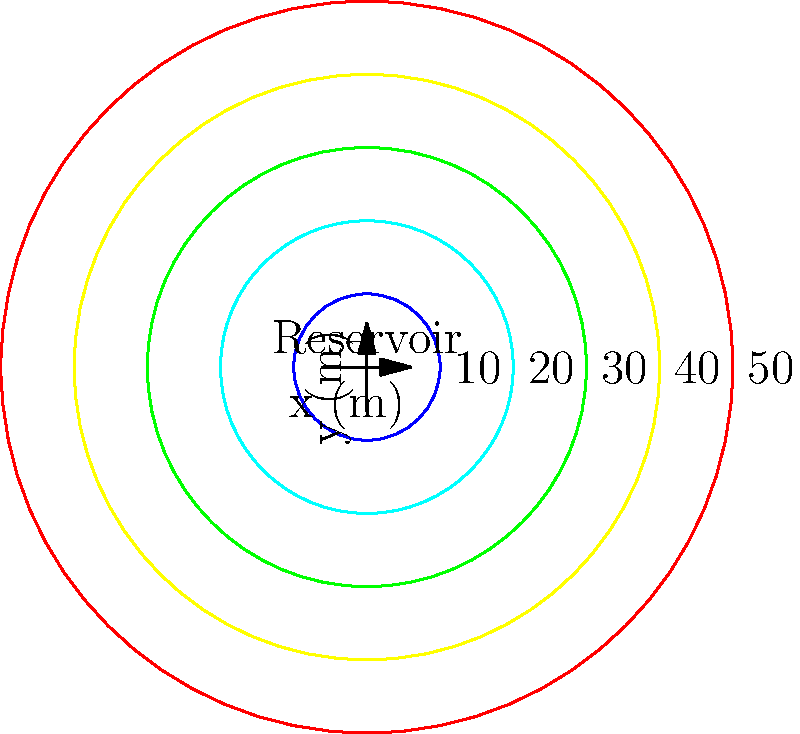A circular reservoir affected by mining runoff is represented by the contour map above, where each contour line indicates a depth in meters. If the reservoir has a maximum depth of 50 meters at its center and a radius of 50 meters, calculate its total volume in cubic meters. Assume the reservoir has a conical shape. To calculate the volume of the conical reservoir, we'll follow these steps:

1) The formula for the volume of a cone is:
   $$V = \frac{1}{3}\pi r^2 h$$
   where $r$ is the radius of the base and $h$ is the height.

2) From the given information:
   Radius ($r$) = 50 meters
   Height ($h$) = 50 meters

3) Substituting these values into the formula:
   $$V = \frac{1}{3}\pi (50\text{ m})^2 (50\text{ m})$$

4) Simplify:
   $$V = \frac{1}{3}\pi (2500\text{ m}^2) (50\text{ m})$$
   $$V = \frac{1}{3}\pi (125000\text{ m}^3)$$

5) Calculate:
   $$V \approx 130899.7\text{ m}^3$$

6) Rounding to the nearest whole number:
   $$V \approx 130900\text{ m}^3$$

Therefore, the total volume of the reservoir is approximately 130,900 cubic meters.
Answer: 130,900 m³ 